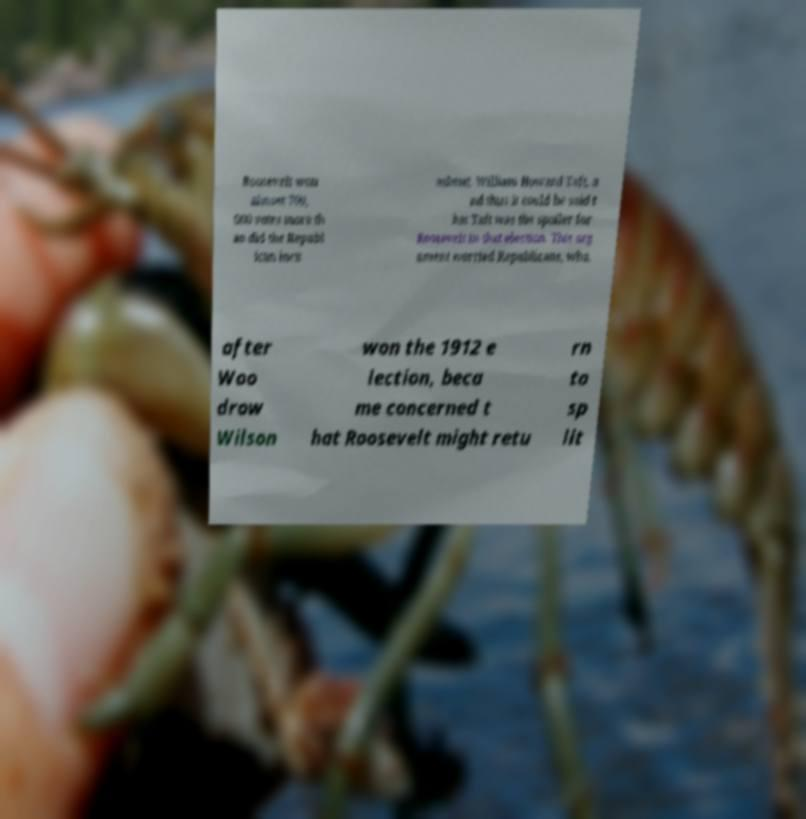For documentation purposes, I need the text within this image transcribed. Could you provide that? Roosevelt won almost 700, 000 votes more th an did the Republ ican incu mbent, William Howard Taft, a nd thus it could be said t hat Taft was the spoiler for Roosevelt in that election. This arg ument worried Republicans, who, after Woo drow Wilson won the 1912 e lection, beca me concerned t hat Roosevelt might retu rn to sp lit 